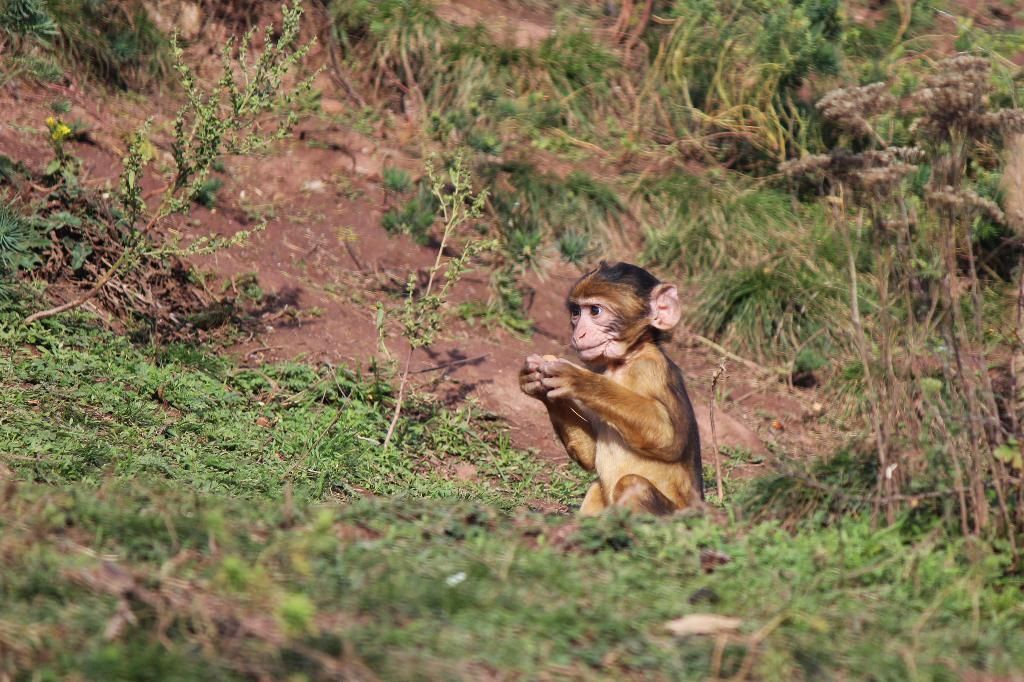What is the main subject in the center of the image? There is a monkey in the center of the image. What can be seen in the background of the image? There are plants and grass in the background of the image. What is the price of the peace symbol in the image? There is no peace symbol or any indication of a price in the image. 